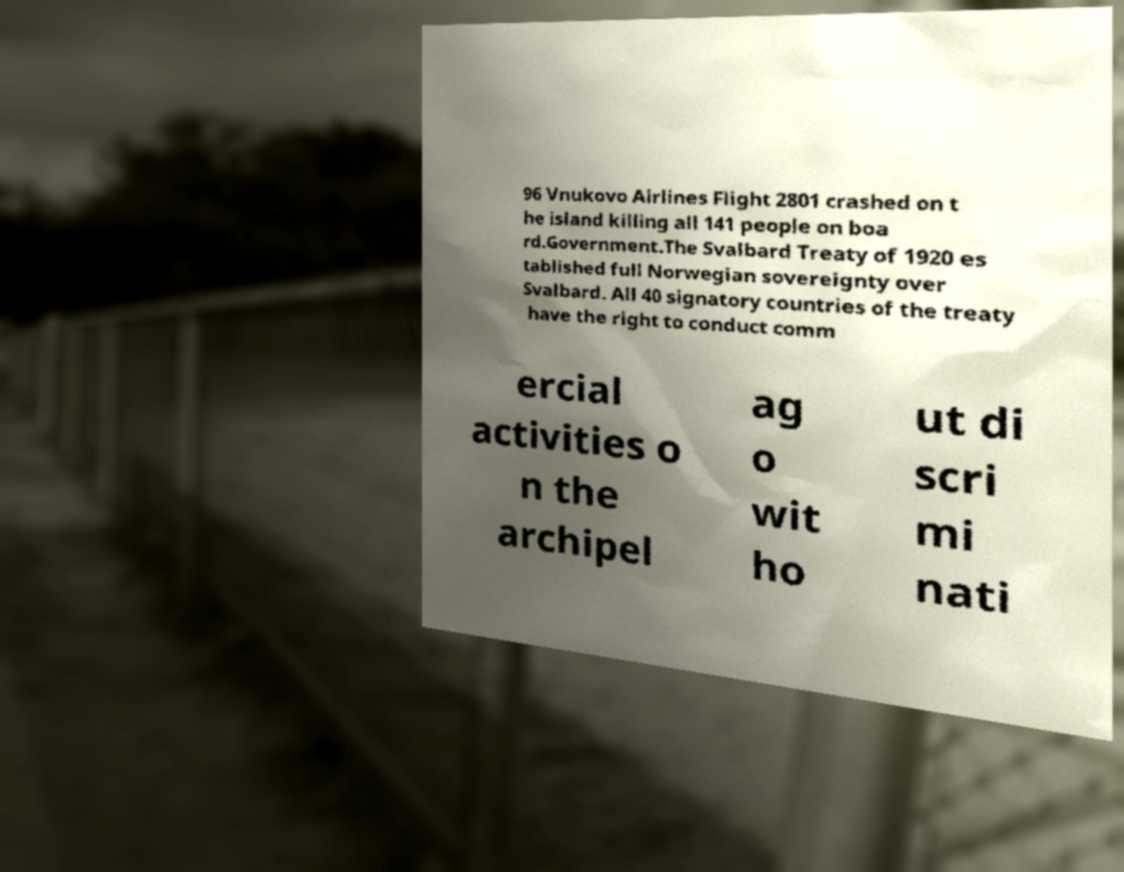Can you read and provide the text displayed in the image?This photo seems to have some interesting text. Can you extract and type it out for me? 96 Vnukovo Airlines Flight 2801 crashed on t he island killing all 141 people on boa rd.Government.The Svalbard Treaty of 1920 es tablished full Norwegian sovereignty over Svalbard. All 40 signatory countries of the treaty have the right to conduct comm ercial activities o n the archipel ag o wit ho ut di scri mi nati 